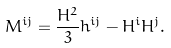<formula> <loc_0><loc_0><loc_500><loc_500>M ^ { i j } = \frac { H ^ { 2 } } { 3 } h ^ { i j } - H ^ { i } H ^ { j } .</formula> 